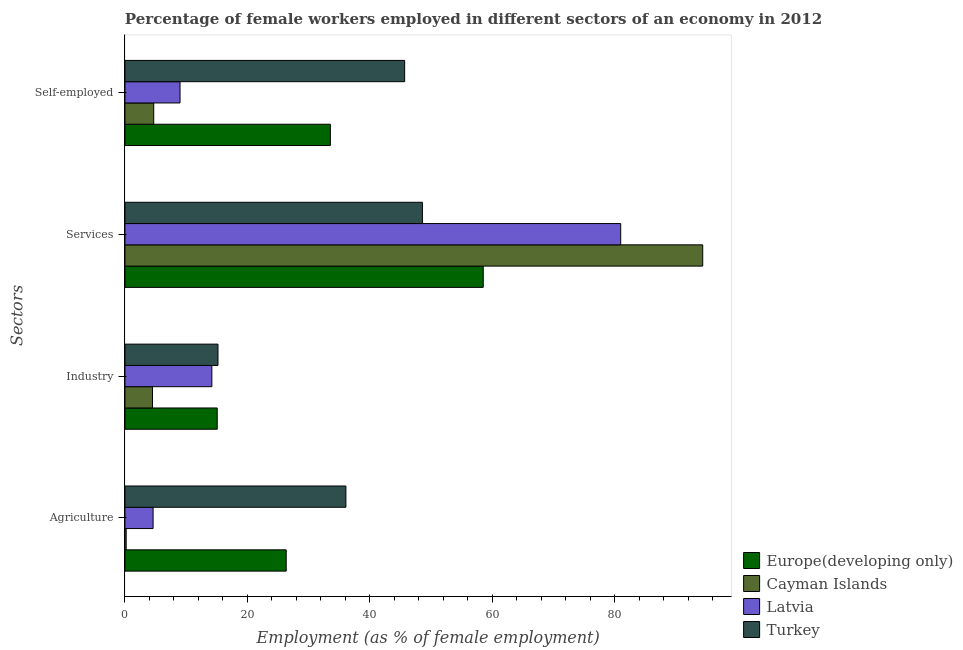How many different coloured bars are there?
Provide a succinct answer. 4. Are the number of bars on each tick of the Y-axis equal?
Your answer should be compact. Yes. How many bars are there on the 2nd tick from the bottom?
Provide a succinct answer. 4. What is the label of the 3rd group of bars from the top?
Offer a very short reply. Industry. What is the percentage of female workers in services in Turkey?
Make the answer very short. 48.6. Across all countries, what is the maximum percentage of female workers in services?
Keep it short and to the point. 94.4. Across all countries, what is the minimum percentage of female workers in industry?
Keep it short and to the point. 4.5. In which country was the percentage of female workers in agriculture maximum?
Keep it short and to the point. Turkey. In which country was the percentage of female workers in agriculture minimum?
Provide a succinct answer. Cayman Islands. What is the total percentage of female workers in industry in the graph?
Provide a succinct answer. 48.98. What is the difference between the percentage of female workers in industry in Latvia and that in Cayman Islands?
Your response must be concise. 9.7. What is the difference between the percentage of self employed female workers in Europe(developing only) and the percentage of female workers in industry in Cayman Islands?
Provide a short and direct response. 29.07. What is the average percentage of female workers in industry per country?
Your response must be concise. 12.24. What is the difference between the percentage of female workers in services and percentage of female workers in agriculture in Europe(developing only)?
Give a very brief answer. 32.19. In how many countries, is the percentage of female workers in services greater than 64 %?
Provide a succinct answer. 2. What is the ratio of the percentage of female workers in industry in Turkey to that in Cayman Islands?
Provide a succinct answer. 3.38. Is the percentage of self employed female workers in Latvia less than that in Europe(developing only)?
Keep it short and to the point. Yes. Is the difference between the percentage of female workers in agriculture in Turkey and Cayman Islands greater than the difference between the percentage of female workers in industry in Turkey and Cayman Islands?
Your response must be concise. Yes. What is the difference between the highest and the second highest percentage of female workers in services?
Your answer should be compact. 13.4. What is the difference between the highest and the lowest percentage of self employed female workers?
Provide a succinct answer. 41. In how many countries, is the percentage of female workers in agriculture greater than the average percentage of female workers in agriculture taken over all countries?
Ensure brevity in your answer.  2. Is the sum of the percentage of female workers in services in Latvia and Turkey greater than the maximum percentage of female workers in industry across all countries?
Your answer should be compact. Yes. Is it the case that in every country, the sum of the percentage of female workers in services and percentage of female workers in agriculture is greater than the sum of percentage of self employed female workers and percentage of female workers in industry?
Keep it short and to the point. Yes. What does the 3rd bar from the top in Services represents?
Keep it short and to the point. Cayman Islands. What does the 3rd bar from the bottom in Industry represents?
Offer a terse response. Latvia. Are the values on the major ticks of X-axis written in scientific E-notation?
Offer a very short reply. No. Does the graph contain any zero values?
Your answer should be very brief. No. Where does the legend appear in the graph?
Make the answer very short. Bottom right. How are the legend labels stacked?
Your answer should be compact. Vertical. What is the title of the graph?
Give a very brief answer. Percentage of female workers employed in different sectors of an economy in 2012. What is the label or title of the X-axis?
Offer a very short reply. Employment (as % of female employment). What is the label or title of the Y-axis?
Your response must be concise. Sectors. What is the Employment (as % of female employment) of Europe(developing only) in Agriculture?
Your response must be concise. 26.35. What is the Employment (as % of female employment) in Cayman Islands in Agriculture?
Give a very brief answer. 0.2. What is the Employment (as % of female employment) of Latvia in Agriculture?
Make the answer very short. 4.6. What is the Employment (as % of female employment) in Turkey in Agriculture?
Your answer should be very brief. 36.1. What is the Employment (as % of female employment) of Europe(developing only) in Industry?
Give a very brief answer. 15.08. What is the Employment (as % of female employment) of Cayman Islands in Industry?
Give a very brief answer. 4.5. What is the Employment (as % of female employment) in Latvia in Industry?
Give a very brief answer. 14.2. What is the Employment (as % of female employment) of Turkey in Industry?
Provide a short and direct response. 15.2. What is the Employment (as % of female employment) of Europe(developing only) in Services?
Give a very brief answer. 58.54. What is the Employment (as % of female employment) of Cayman Islands in Services?
Give a very brief answer. 94.4. What is the Employment (as % of female employment) in Latvia in Services?
Provide a short and direct response. 81. What is the Employment (as % of female employment) in Turkey in Services?
Your answer should be very brief. 48.6. What is the Employment (as % of female employment) in Europe(developing only) in Self-employed?
Your response must be concise. 33.57. What is the Employment (as % of female employment) in Cayman Islands in Self-employed?
Your answer should be compact. 4.7. What is the Employment (as % of female employment) in Latvia in Self-employed?
Give a very brief answer. 9. What is the Employment (as % of female employment) in Turkey in Self-employed?
Your answer should be very brief. 45.7. Across all Sectors, what is the maximum Employment (as % of female employment) of Europe(developing only)?
Provide a short and direct response. 58.54. Across all Sectors, what is the maximum Employment (as % of female employment) in Cayman Islands?
Make the answer very short. 94.4. Across all Sectors, what is the maximum Employment (as % of female employment) in Turkey?
Provide a short and direct response. 48.6. Across all Sectors, what is the minimum Employment (as % of female employment) in Europe(developing only)?
Your answer should be very brief. 15.08. Across all Sectors, what is the minimum Employment (as % of female employment) in Cayman Islands?
Your response must be concise. 0.2. Across all Sectors, what is the minimum Employment (as % of female employment) in Latvia?
Provide a short and direct response. 4.6. Across all Sectors, what is the minimum Employment (as % of female employment) in Turkey?
Keep it short and to the point. 15.2. What is the total Employment (as % of female employment) of Europe(developing only) in the graph?
Ensure brevity in your answer.  133.53. What is the total Employment (as % of female employment) in Cayman Islands in the graph?
Your answer should be compact. 103.8. What is the total Employment (as % of female employment) of Latvia in the graph?
Make the answer very short. 108.8. What is the total Employment (as % of female employment) in Turkey in the graph?
Provide a succinct answer. 145.6. What is the difference between the Employment (as % of female employment) of Europe(developing only) in Agriculture and that in Industry?
Provide a short and direct response. 11.27. What is the difference between the Employment (as % of female employment) in Cayman Islands in Agriculture and that in Industry?
Give a very brief answer. -4.3. What is the difference between the Employment (as % of female employment) in Latvia in Agriculture and that in Industry?
Your answer should be compact. -9.6. What is the difference between the Employment (as % of female employment) in Turkey in Agriculture and that in Industry?
Keep it short and to the point. 20.9. What is the difference between the Employment (as % of female employment) of Europe(developing only) in Agriculture and that in Services?
Your response must be concise. -32.19. What is the difference between the Employment (as % of female employment) of Cayman Islands in Agriculture and that in Services?
Keep it short and to the point. -94.2. What is the difference between the Employment (as % of female employment) of Latvia in Agriculture and that in Services?
Provide a short and direct response. -76.4. What is the difference between the Employment (as % of female employment) of Europe(developing only) in Agriculture and that in Self-employed?
Offer a terse response. -7.22. What is the difference between the Employment (as % of female employment) of Latvia in Agriculture and that in Self-employed?
Your answer should be compact. -4.4. What is the difference between the Employment (as % of female employment) of Turkey in Agriculture and that in Self-employed?
Your answer should be compact. -9.6. What is the difference between the Employment (as % of female employment) in Europe(developing only) in Industry and that in Services?
Provide a succinct answer. -43.46. What is the difference between the Employment (as % of female employment) in Cayman Islands in Industry and that in Services?
Make the answer very short. -89.9. What is the difference between the Employment (as % of female employment) in Latvia in Industry and that in Services?
Offer a very short reply. -66.8. What is the difference between the Employment (as % of female employment) of Turkey in Industry and that in Services?
Offer a terse response. -33.4. What is the difference between the Employment (as % of female employment) in Europe(developing only) in Industry and that in Self-employed?
Your answer should be very brief. -18.49. What is the difference between the Employment (as % of female employment) of Latvia in Industry and that in Self-employed?
Provide a short and direct response. 5.2. What is the difference between the Employment (as % of female employment) in Turkey in Industry and that in Self-employed?
Your answer should be very brief. -30.5. What is the difference between the Employment (as % of female employment) in Europe(developing only) in Services and that in Self-employed?
Provide a short and direct response. 24.97. What is the difference between the Employment (as % of female employment) in Cayman Islands in Services and that in Self-employed?
Make the answer very short. 89.7. What is the difference between the Employment (as % of female employment) of Latvia in Services and that in Self-employed?
Your response must be concise. 72. What is the difference between the Employment (as % of female employment) of Turkey in Services and that in Self-employed?
Keep it short and to the point. 2.9. What is the difference between the Employment (as % of female employment) of Europe(developing only) in Agriculture and the Employment (as % of female employment) of Cayman Islands in Industry?
Your answer should be compact. 21.85. What is the difference between the Employment (as % of female employment) of Europe(developing only) in Agriculture and the Employment (as % of female employment) of Latvia in Industry?
Provide a succinct answer. 12.15. What is the difference between the Employment (as % of female employment) in Europe(developing only) in Agriculture and the Employment (as % of female employment) in Turkey in Industry?
Offer a very short reply. 11.15. What is the difference between the Employment (as % of female employment) in Latvia in Agriculture and the Employment (as % of female employment) in Turkey in Industry?
Make the answer very short. -10.6. What is the difference between the Employment (as % of female employment) of Europe(developing only) in Agriculture and the Employment (as % of female employment) of Cayman Islands in Services?
Keep it short and to the point. -68.05. What is the difference between the Employment (as % of female employment) of Europe(developing only) in Agriculture and the Employment (as % of female employment) of Latvia in Services?
Provide a short and direct response. -54.65. What is the difference between the Employment (as % of female employment) in Europe(developing only) in Agriculture and the Employment (as % of female employment) in Turkey in Services?
Offer a terse response. -22.25. What is the difference between the Employment (as % of female employment) of Cayman Islands in Agriculture and the Employment (as % of female employment) of Latvia in Services?
Make the answer very short. -80.8. What is the difference between the Employment (as % of female employment) of Cayman Islands in Agriculture and the Employment (as % of female employment) of Turkey in Services?
Ensure brevity in your answer.  -48.4. What is the difference between the Employment (as % of female employment) in Latvia in Agriculture and the Employment (as % of female employment) in Turkey in Services?
Make the answer very short. -44. What is the difference between the Employment (as % of female employment) of Europe(developing only) in Agriculture and the Employment (as % of female employment) of Cayman Islands in Self-employed?
Your answer should be compact. 21.65. What is the difference between the Employment (as % of female employment) in Europe(developing only) in Agriculture and the Employment (as % of female employment) in Latvia in Self-employed?
Make the answer very short. 17.35. What is the difference between the Employment (as % of female employment) in Europe(developing only) in Agriculture and the Employment (as % of female employment) in Turkey in Self-employed?
Your answer should be very brief. -19.35. What is the difference between the Employment (as % of female employment) in Cayman Islands in Agriculture and the Employment (as % of female employment) in Latvia in Self-employed?
Offer a very short reply. -8.8. What is the difference between the Employment (as % of female employment) of Cayman Islands in Agriculture and the Employment (as % of female employment) of Turkey in Self-employed?
Offer a very short reply. -45.5. What is the difference between the Employment (as % of female employment) in Latvia in Agriculture and the Employment (as % of female employment) in Turkey in Self-employed?
Offer a very short reply. -41.1. What is the difference between the Employment (as % of female employment) in Europe(developing only) in Industry and the Employment (as % of female employment) in Cayman Islands in Services?
Your answer should be compact. -79.32. What is the difference between the Employment (as % of female employment) of Europe(developing only) in Industry and the Employment (as % of female employment) of Latvia in Services?
Your answer should be compact. -65.92. What is the difference between the Employment (as % of female employment) of Europe(developing only) in Industry and the Employment (as % of female employment) of Turkey in Services?
Offer a very short reply. -33.52. What is the difference between the Employment (as % of female employment) in Cayman Islands in Industry and the Employment (as % of female employment) in Latvia in Services?
Make the answer very short. -76.5. What is the difference between the Employment (as % of female employment) of Cayman Islands in Industry and the Employment (as % of female employment) of Turkey in Services?
Keep it short and to the point. -44.1. What is the difference between the Employment (as % of female employment) of Latvia in Industry and the Employment (as % of female employment) of Turkey in Services?
Make the answer very short. -34.4. What is the difference between the Employment (as % of female employment) in Europe(developing only) in Industry and the Employment (as % of female employment) in Cayman Islands in Self-employed?
Your answer should be compact. 10.38. What is the difference between the Employment (as % of female employment) of Europe(developing only) in Industry and the Employment (as % of female employment) of Latvia in Self-employed?
Provide a short and direct response. 6.08. What is the difference between the Employment (as % of female employment) in Europe(developing only) in Industry and the Employment (as % of female employment) in Turkey in Self-employed?
Keep it short and to the point. -30.62. What is the difference between the Employment (as % of female employment) of Cayman Islands in Industry and the Employment (as % of female employment) of Latvia in Self-employed?
Keep it short and to the point. -4.5. What is the difference between the Employment (as % of female employment) in Cayman Islands in Industry and the Employment (as % of female employment) in Turkey in Self-employed?
Offer a very short reply. -41.2. What is the difference between the Employment (as % of female employment) of Latvia in Industry and the Employment (as % of female employment) of Turkey in Self-employed?
Keep it short and to the point. -31.5. What is the difference between the Employment (as % of female employment) of Europe(developing only) in Services and the Employment (as % of female employment) of Cayman Islands in Self-employed?
Provide a short and direct response. 53.84. What is the difference between the Employment (as % of female employment) in Europe(developing only) in Services and the Employment (as % of female employment) in Latvia in Self-employed?
Make the answer very short. 49.54. What is the difference between the Employment (as % of female employment) of Europe(developing only) in Services and the Employment (as % of female employment) of Turkey in Self-employed?
Give a very brief answer. 12.84. What is the difference between the Employment (as % of female employment) in Cayman Islands in Services and the Employment (as % of female employment) in Latvia in Self-employed?
Provide a short and direct response. 85.4. What is the difference between the Employment (as % of female employment) of Cayman Islands in Services and the Employment (as % of female employment) of Turkey in Self-employed?
Make the answer very short. 48.7. What is the difference between the Employment (as % of female employment) of Latvia in Services and the Employment (as % of female employment) of Turkey in Self-employed?
Offer a terse response. 35.3. What is the average Employment (as % of female employment) in Europe(developing only) per Sectors?
Your response must be concise. 33.38. What is the average Employment (as % of female employment) of Cayman Islands per Sectors?
Offer a terse response. 25.95. What is the average Employment (as % of female employment) of Latvia per Sectors?
Keep it short and to the point. 27.2. What is the average Employment (as % of female employment) in Turkey per Sectors?
Give a very brief answer. 36.4. What is the difference between the Employment (as % of female employment) in Europe(developing only) and Employment (as % of female employment) in Cayman Islands in Agriculture?
Keep it short and to the point. 26.15. What is the difference between the Employment (as % of female employment) in Europe(developing only) and Employment (as % of female employment) in Latvia in Agriculture?
Give a very brief answer. 21.75. What is the difference between the Employment (as % of female employment) in Europe(developing only) and Employment (as % of female employment) in Turkey in Agriculture?
Ensure brevity in your answer.  -9.75. What is the difference between the Employment (as % of female employment) of Cayman Islands and Employment (as % of female employment) of Latvia in Agriculture?
Provide a short and direct response. -4.4. What is the difference between the Employment (as % of female employment) of Cayman Islands and Employment (as % of female employment) of Turkey in Agriculture?
Keep it short and to the point. -35.9. What is the difference between the Employment (as % of female employment) of Latvia and Employment (as % of female employment) of Turkey in Agriculture?
Your answer should be very brief. -31.5. What is the difference between the Employment (as % of female employment) of Europe(developing only) and Employment (as % of female employment) of Cayman Islands in Industry?
Your answer should be compact. 10.58. What is the difference between the Employment (as % of female employment) of Europe(developing only) and Employment (as % of female employment) of Latvia in Industry?
Make the answer very short. 0.88. What is the difference between the Employment (as % of female employment) in Europe(developing only) and Employment (as % of female employment) in Turkey in Industry?
Give a very brief answer. -0.12. What is the difference between the Employment (as % of female employment) of Cayman Islands and Employment (as % of female employment) of Latvia in Industry?
Keep it short and to the point. -9.7. What is the difference between the Employment (as % of female employment) of Europe(developing only) and Employment (as % of female employment) of Cayman Islands in Services?
Ensure brevity in your answer.  -35.86. What is the difference between the Employment (as % of female employment) of Europe(developing only) and Employment (as % of female employment) of Latvia in Services?
Ensure brevity in your answer.  -22.46. What is the difference between the Employment (as % of female employment) of Europe(developing only) and Employment (as % of female employment) of Turkey in Services?
Offer a terse response. 9.94. What is the difference between the Employment (as % of female employment) of Cayman Islands and Employment (as % of female employment) of Latvia in Services?
Provide a succinct answer. 13.4. What is the difference between the Employment (as % of female employment) of Cayman Islands and Employment (as % of female employment) of Turkey in Services?
Ensure brevity in your answer.  45.8. What is the difference between the Employment (as % of female employment) of Latvia and Employment (as % of female employment) of Turkey in Services?
Your response must be concise. 32.4. What is the difference between the Employment (as % of female employment) of Europe(developing only) and Employment (as % of female employment) of Cayman Islands in Self-employed?
Keep it short and to the point. 28.87. What is the difference between the Employment (as % of female employment) in Europe(developing only) and Employment (as % of female employment) in Latvia in Self-employed?
Offer a terse response. 24.57. What is the difference between the Employment (as % of female employment) in Europe(developing only) and Employment (as % of female employment) in Turkey in Self-employed?
Give a very brief answer. -12.13. What is the difference between the Employment (as % of female employment) of Cayman Islands and Employment (as % of female employment) of Latvia in Self-employed?
Your answer should be very brief. -4.3. What is the difference between the Employment (as % of female employment) of Cayman Islands and Employment (as % of female employment) of Turkey in Self-employed?
Keep it short and to the point. -41. What is the difference between the Employment (as % of female employment) in Latvia and Employment (as % of female employment) in Turkey in Self-employed?
Give a very brief answer. -36.7. What is the ratio of the Employment (as % of female employment) in Europe(developing only) in Agriculture to that in Industry?
Offer a very short reply. 1.75. What is the ratio of the Employment (as % of female employment) in Cayman Islands in Agriculture to that in Industry?
Your answer should be compact. 0.04. What is the ratio of the Employment (as % of female employment) of Latvia in Agriculture to that in Industry?
Your answer should be very brief. 0.32. What is the ratio of the Employment (as % of female employment) of Turkey in Agriculture to that in Industry?
Provide a succinct answer. 2.38. What is the ratio of the Employment (as % of female employment) in Europe(developing only) in Agriculture to that in Services?
Your answer should be very brief. 0.45. What is the ratio of the Employment (as % of female employment) of Cayman Islands in Agriculture to that in Services?
Ensure brevity in your answer.  0. What is the ratio of the Employment (as % of female employment) of Latvia in Agriculture to that in Services?
Provide a succinct answer. 0.06. What is the ratio of the Employment (as % of female employment) of Turkey in Agriculture to that in Services?
Your response must be concise. 0.74. What is the ratio of the Employment (as % of female employment) of Europe(developing only) in Agriculture to that in Self-employed?
Your answer should be compact. 0.79. What is the ratio of the Employment (as % of female employment) in Cayman Islands in Agriculture to that in Self-employed?
Offer a very short reply. 0.04. What is the ratio of the Employment (as % of female employment) in Latvia in Agriculture to that in Self-employed?
Your answer should be compact. 0.51. What is the ratio of the Employment (as % of female employment) of Turkey in Agriculture to that in Self-employed?
Keep it short and to the point. 0.79. What is the ratio of the Employment (as % of female employment) of Europe(developing only) in Industry to that in Services?
Provide a succinct answer. 0.26. What is the ratio of the Employment (as % of female employment) of Cayman Islands in Industry to that in Services?
Make the answer very short. 0.05. What is the ratio of the Employment (as % of female employment) in Latvia in Industry to that in Services?
Make the answer very short. 0.18. What is the ratio of the Employment (as % of female employment) in Turkey in Industry to that in Services?
Provide a short and direct response. 0.31. What is the ratio of the Employment (as % of female employment) of Europe(developing only) in Industry to that in Self-employed?
Make the answer very short. 0.45. What is the ratio of the Employment (as % of female employment) of Cayman Islands in Industry to that in Self-employed?
Offer a very short reply. 0.96. What is the ratio of the Employment (as % of female employment) in Latvia in Industry to that in Self-employed?
Your answer should be compact. 1.58. What is the ratio of the Employment (as % of female employment) in Turkey in Industry to that in Self-employed?
Offer a terse response. 0.33. What is the ratio of the Employment (as % of female employment) in Europe(developing only) in Services to that in Self-employed?
Offer a terse response. 1.74. What is the ratio of the Employment (as % of female employment) of Cayman Islands in Services to that in Self-employed?
Your answer should be very brief. 20.09. What is the ratio of the Employment (as % of female employment) in Latvia in Services to that in Self-employed?
Your response must be concise. 9. What is the ratio of the Employment (as % of female employment) in Turkey in Services to that in Self-employed?
Your answer should be very brief. 1.06. What is the difference between the highest and the second highest Employment (as % of female employment) in Europe(developing only)?
Your answer should be compact. 24.97. What is the difference between the highest and the second highest Employment (as % of female employment) of Cayman Islands?
Provide a short and direct response. 89.7. What is the difference between the highest and the second highest Employment (as % of female employment) in Latvia?
Ensure brevity in your answer.  66.8. What is the difference between the highest and the lowest Employment (as % of female employment) of Europe(developing only)?
Ensure brevity in your answer.  43.46. What is the difference between the highest and the lowest Employment (as % of female employment) of Cayman Islands?
Your answer should be very brief. 94.2. What is the difference between the highest and the lowest Employment (as % of female employment) of Latvia?
Offer a very short reply. 76.4. What is the difference between the highest and the lowest Employment (as % of female employment) of Turkey?
Offer a very short reply. 33.4. 